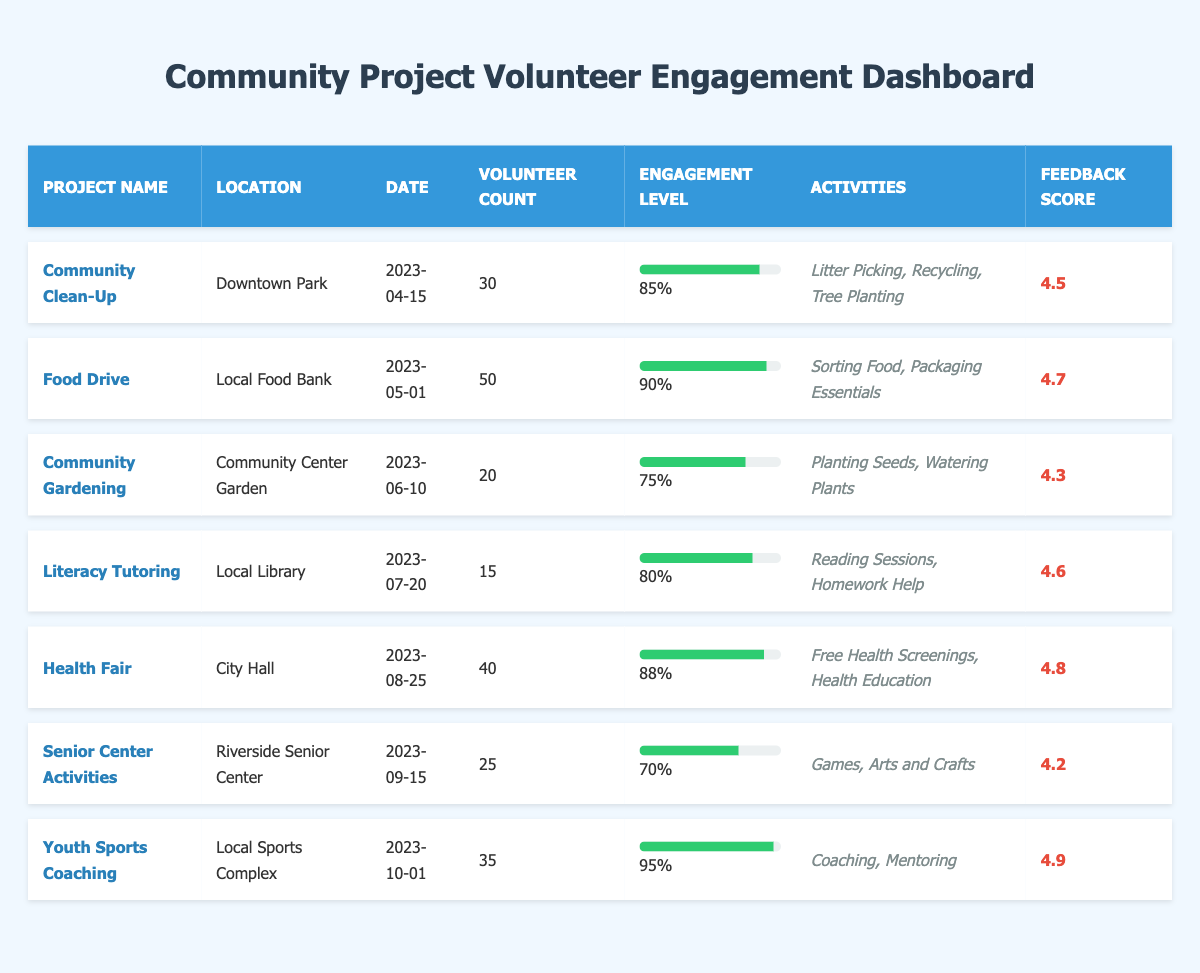What is the volunteer count for the Food Drive project? The table shows that the Food Drive project has a volunteer count of 50, which is explicitly listed under the "Volunteer Count" column.
Answer: 50 Which community project had the highest engagement level? Comparing the engagement levels listed in the table, the Youth Sports Coaching project has the highest engagement level at 0.95.
Answer: Youth Sports Coaching How many total volunteers participated in the Community Clean-Up and the Health Fair projects combined? The Community Clean-Up project has 30 volunteers, and the Health Fair project has 40 volunteers. Adding these together gives 30 + 40 = 70.
Answer: 70 What is the feedback score for the Literacy Tutoring project? According to the table, the Literacy Tutoring project has a feedback score of 4.6, listed under the "Feedback Score" column.
Answer: 4.6 Is the engagement level for Senior Center Activities above 0.75? The engagement level for Senior Center Activities is 0.70, which is below 0.75, making the statement false.
Answer: No What is the average engagement level of all the projects listed? The engagement levels are 0.85, 0.90, 0.75, 0.80, 0.88, 0.70, and 0.95. Adding these gives 0.85 + 0.90 + 0.75 + 0.80 + 0.88 + 0.70 + 0.95 = 5.83. Dividing by the number of projects (7) gives an average engagement level of 5.83 / 7 ≈ 0.833.
Answer: Approximately 0.833 How many projects have a feedback score of 4.5 or higher? Checking the feedback scores in the table, the scores are 4.5, 4.7, 4.3, 4.6, 4.8, 4.2, and 4.9. The scores 4.5, 4.7, 4.6, 4.8, and 4.9 are 4.5 or higher, totaling to 5 projects.
Answer: 5 Which activities were involved in the Community Gardening project? The table lists the activities for the Community Gardening project as "Planting Seeds" and "Watering Plants," found under the "Activities" column.
Answer: Planting Seeds, Watering Plants What is the difference in volunteer count between the Food Drive and Youth Sports Coaching projects? The Food Drive project has 50 volunteers, and the Youth Sports Coaching project has 35 volunteers. The difference is 50 - 35 = 15.
Answer: 15 Which project received the highest feedback score? Looking at the feedback scores, the Youth Sports Coaching project received the highest feedback score of 4.9, which is indicated in the table.
Answer: Youth Sports Coaching Did more volunteers participate in the Health Fair than the Community Gardening project? The Health Fair had 40 volunteers, while Community Gardening had 20 volunteers. Since 40 is greater than 20, the statement is true.
Answer: Yes 